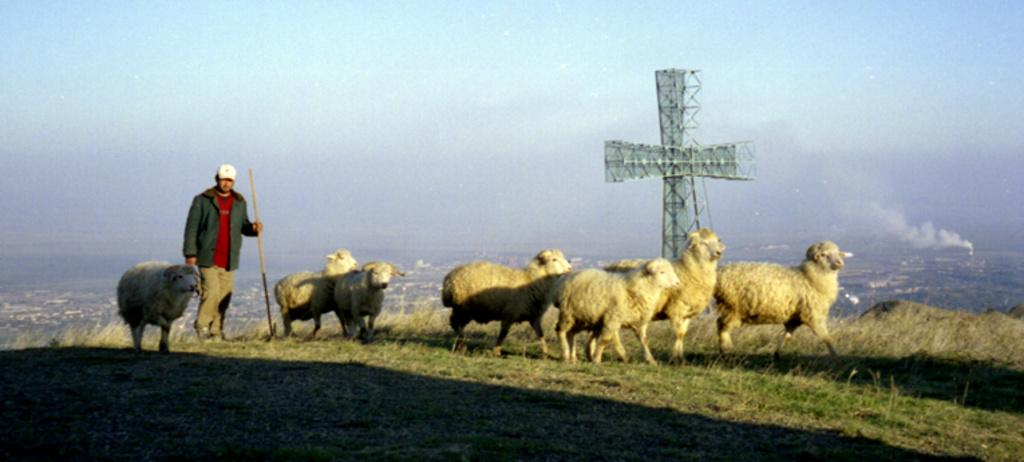What animals can be seen in the image? There are sheep on the grass in the image. What is the person holding in the image? The person is holding a stick in the image. What can be seen in the distance in the image? There is a tower visible in the background of the image. What is visible above the tower in the image? The sky is visible in the background of the image. What type of horn can be seen on the sheep in the image? There are no horns visible on the sheep in the image. What color are the feathers on the sheep in the image? Sheep do not have feathers; they have wool. Can you hear the bell ringing in the image? There is no bell present in the image. 